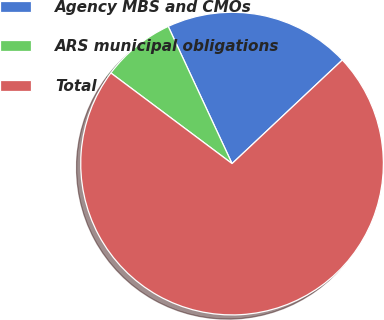Convert chart. <chart><loc_0><loc_0><loc_500><loc_500><pie_chart><fcel>Agency MBS and CMOs<fcel>ARS municipal obligations<fcel>Total<nl><fcel>19.93%<fcel>7.85%<fcel>72.22%<nl></chart> 